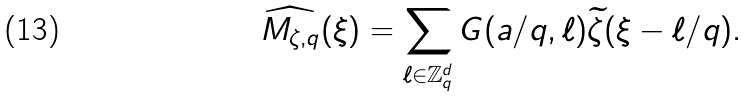<formula> <loc_0><loc_0><loc_500><loc_500>\widehat { M _ { \zeta , q } } ( \xi ) = \sum _ { \ell \in \mathbb { Z } ^ { d } _ { q } } G ( a / q , \ell ) \widetilde { \zeta } ( \xi - \ell / q ) .</formula> 